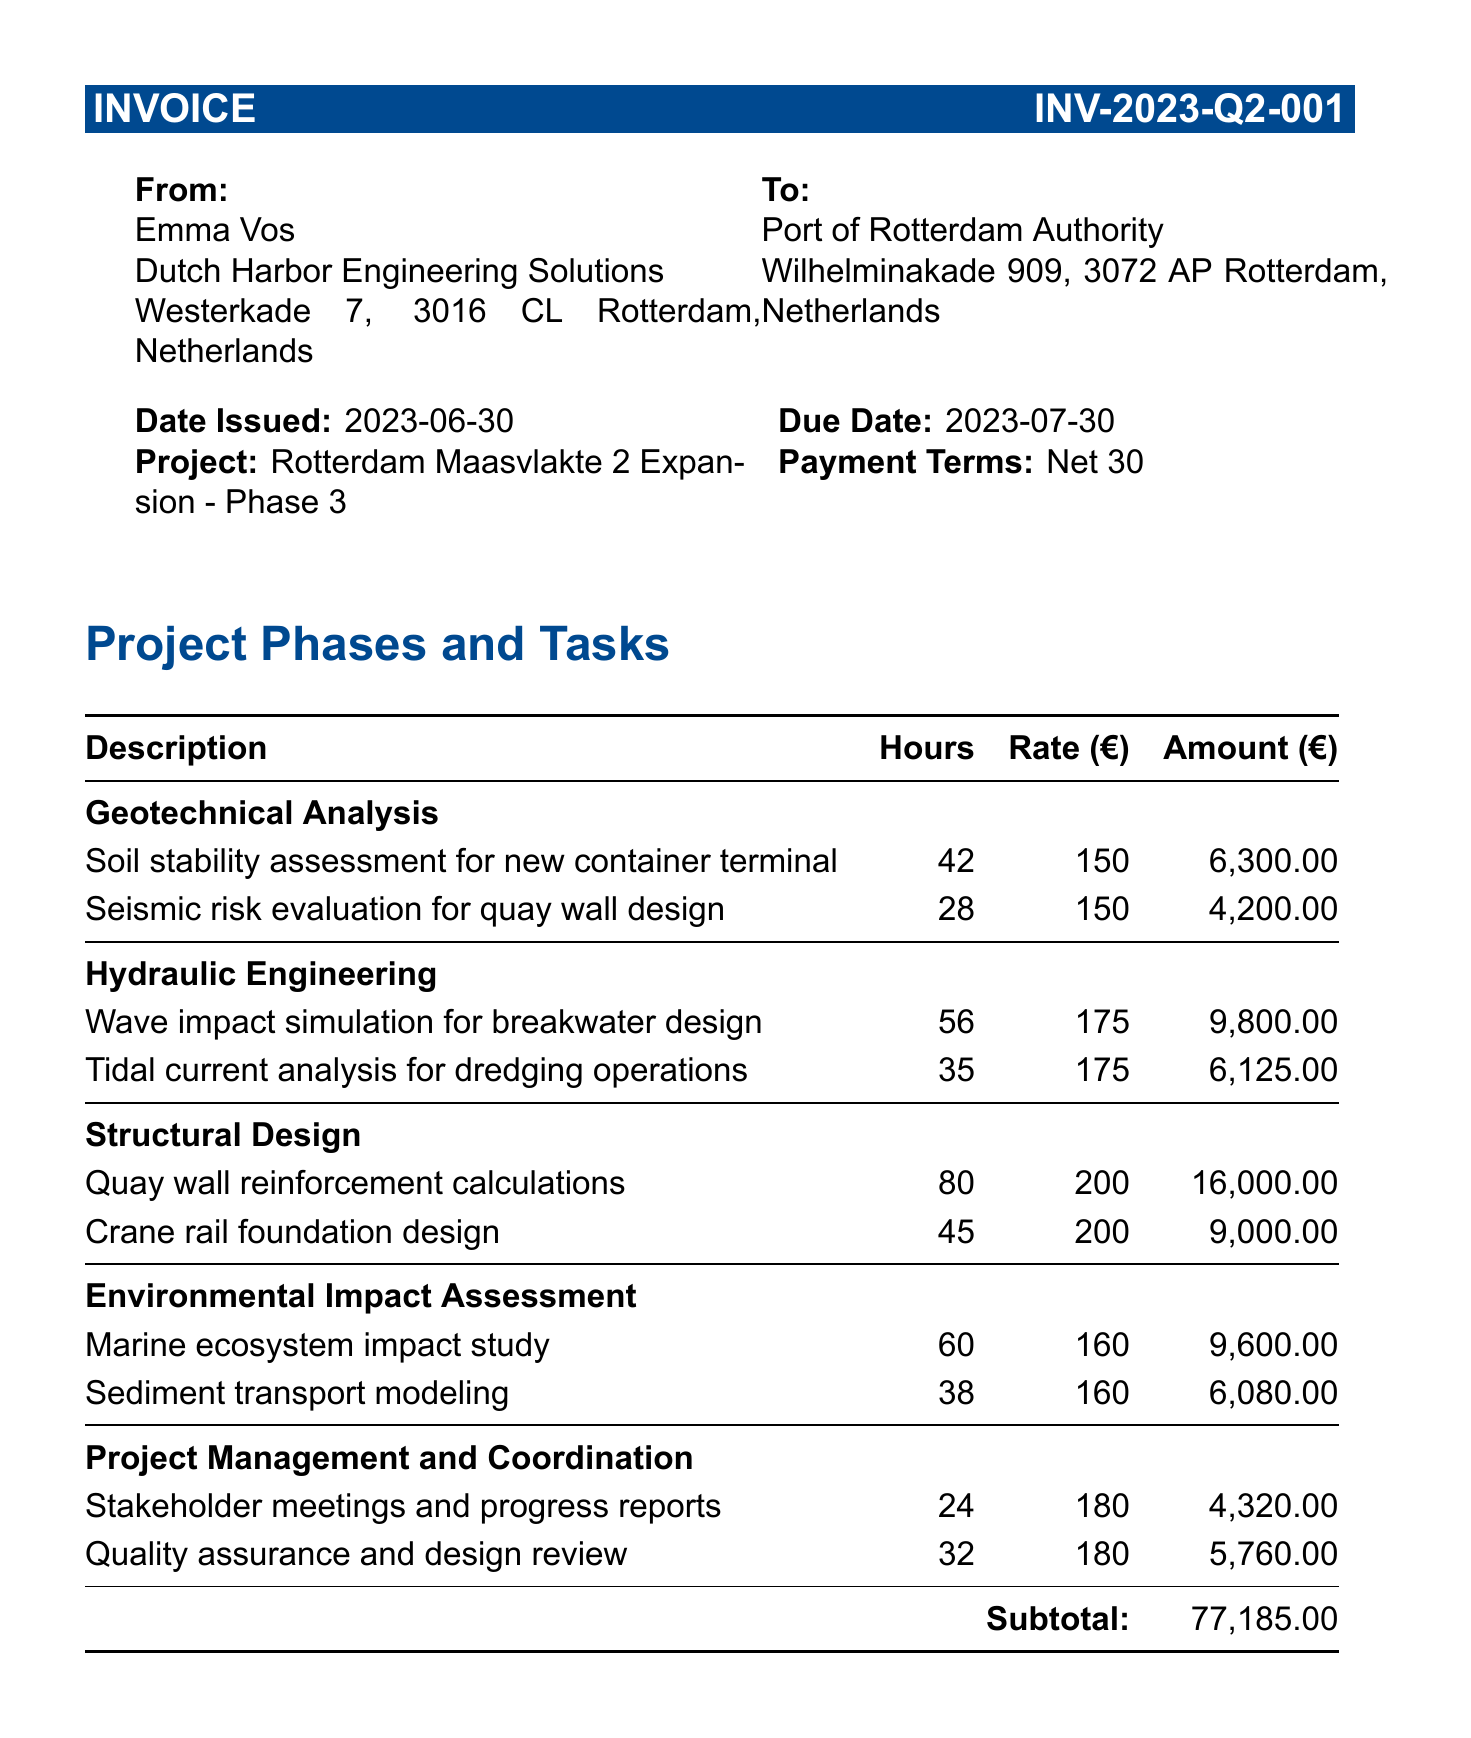what is the invoice number? The invoice number is stated clearly at the top of the document.
Answer: INV-2023-Q2-001 who issued the invoice? The consultant's name is provided in the document, indicating the issuer of the invoice.
Answer: Emma Vos what is the due date for this invoice? The due date is listed in the date section of the invoice.
Answer: 2023-07-30 how many hours were allocated for the "Marine ecosystem impact study"? The number of hours is specified under the corresponding task in the relevant project phase.
Answer: 60 what is the total amount for all project phases combined? This amount is the subtotal calculated from all tasks in the project phases.
Answer: 77,185.00 what is the total additional expenses mentioned? The total additional expenses line summarizes the listed extra costs in the document.
Answer: 4,700.00 what is the total invoice amount? The total invoice amount is presented as the final calculation at the end of the invoice.
Answer: €81,885.00 what is the payment term stated in the invoice? The payment terms are outlined in a specific section of the invoice.
Answer: Net 30 which company is responsible for the consulting services? The name of the consulting company is listed in the consultant information section.
Answer: Dutch Harbor Engineering Solutions 